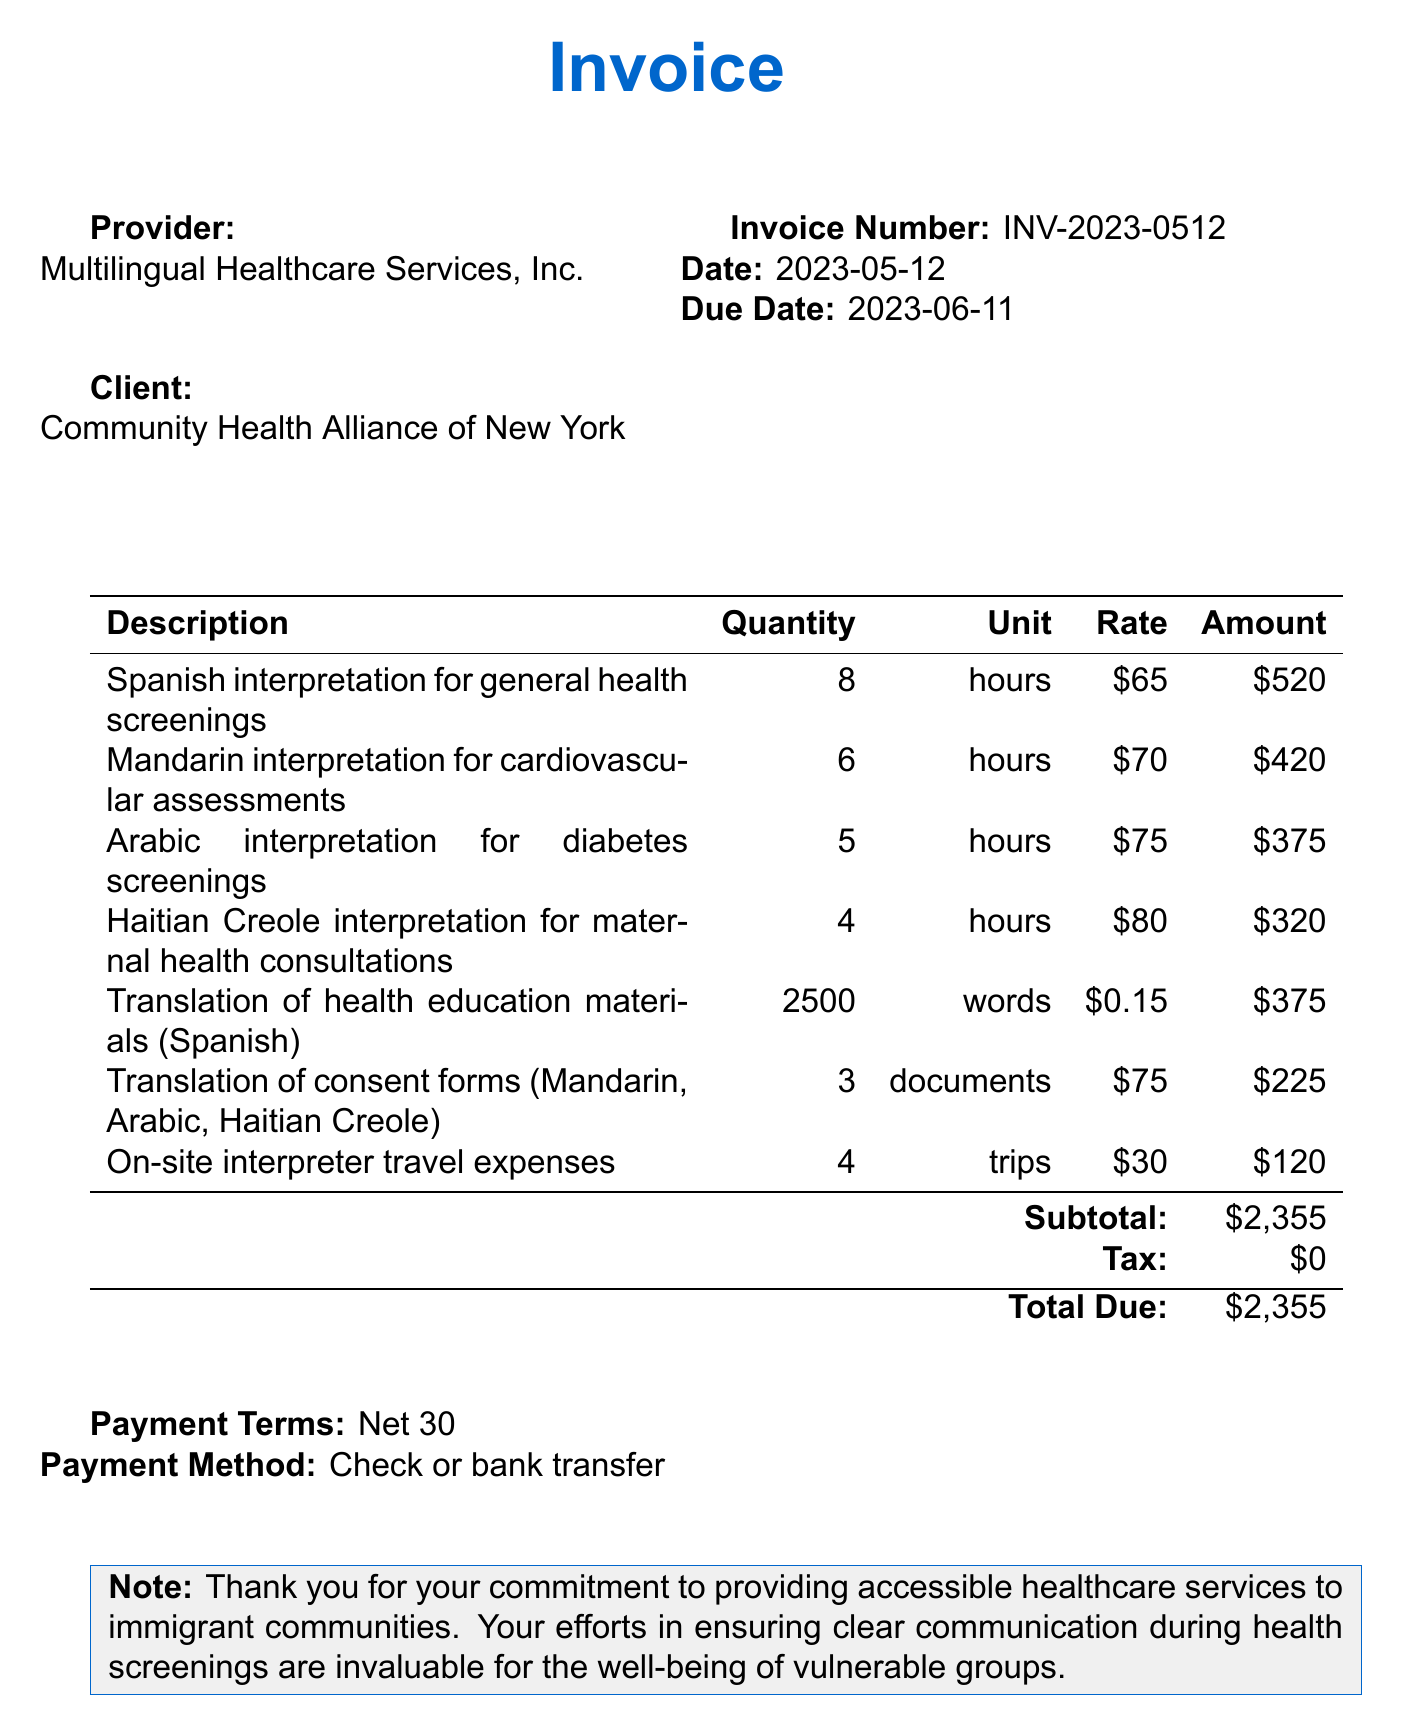What is the invoice number? The invoice number is located at the top right section of the invoice.
Answer: INV-2023-0512 What is the date of the invoice? The date can be found next to the invoice number.
Answer: 2023-05-12 Who is the provider? The provider's name is listed in the top left section of the invoice.
Answer: Multilingual Healthcare Services, Inc What is the total amount due? The total due amount is stated near the bottom of the invoice.
Answer: $2,355 How many hours of Mandarin interpretation were billed? The quantity of Mandarin interpretation hours is listed in the service items table.
Answer: 6 What is the rate for Arabic interpretation? The rate for Arabic interpretation can be found alongside its description in the service items.
Answer: $75 What is the payment term? The payment terms are stated in the additional info section of the invoice.
Answer: Net 30 How many words were translated in health education materials? The quantity of words for health education material translation is specified in the service items.
Answer: 2500 How many trips were billed for on-site interpreter travel expenses? The number of trips is detailed in the service items table.
Answer: 4 